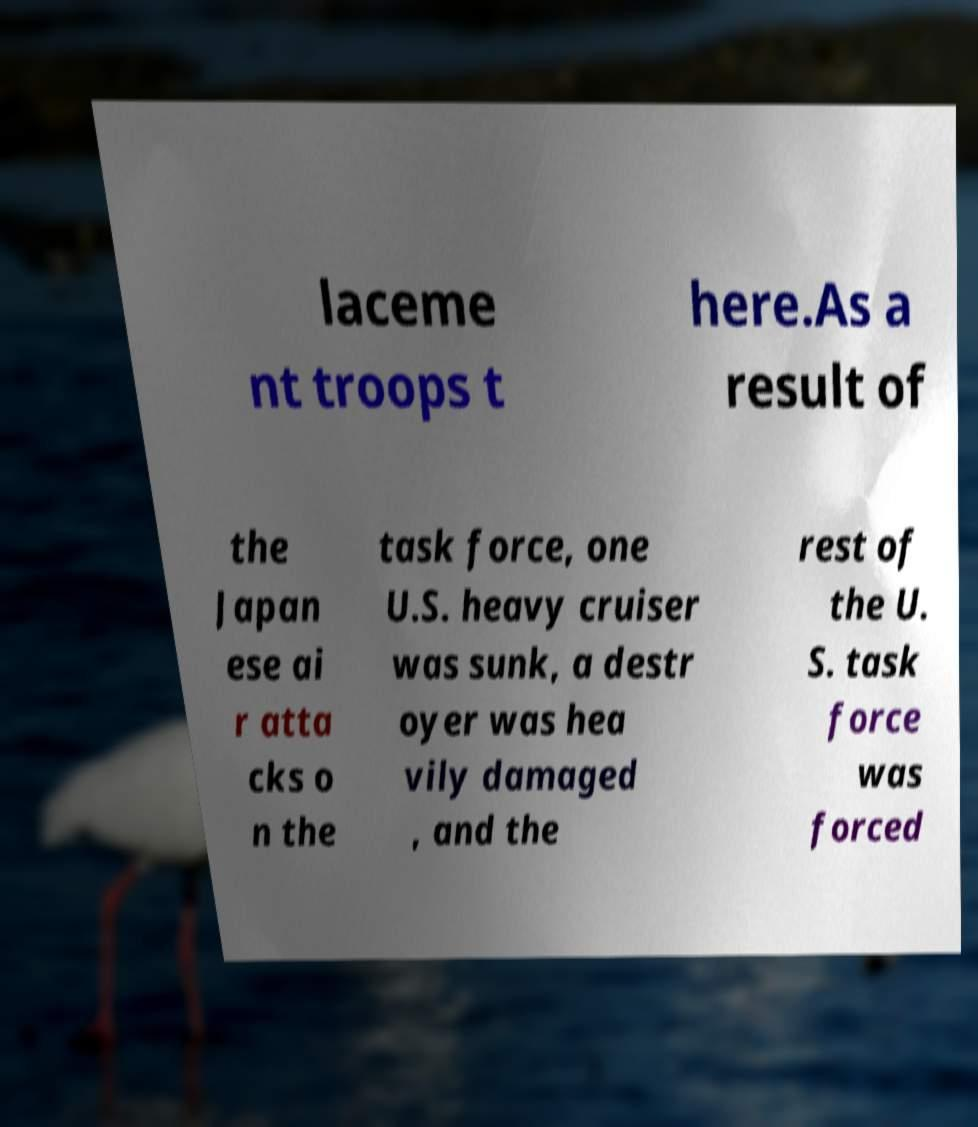Please identify and transcribe the text found in this image. laceme nt troops t here.As a result of the Japan ese ai r atta cks o n the task force, one U.S. heavy cruiser was sunk, a destr oyer was hea vily damaged , and the rest of the U. S. task force was forced 